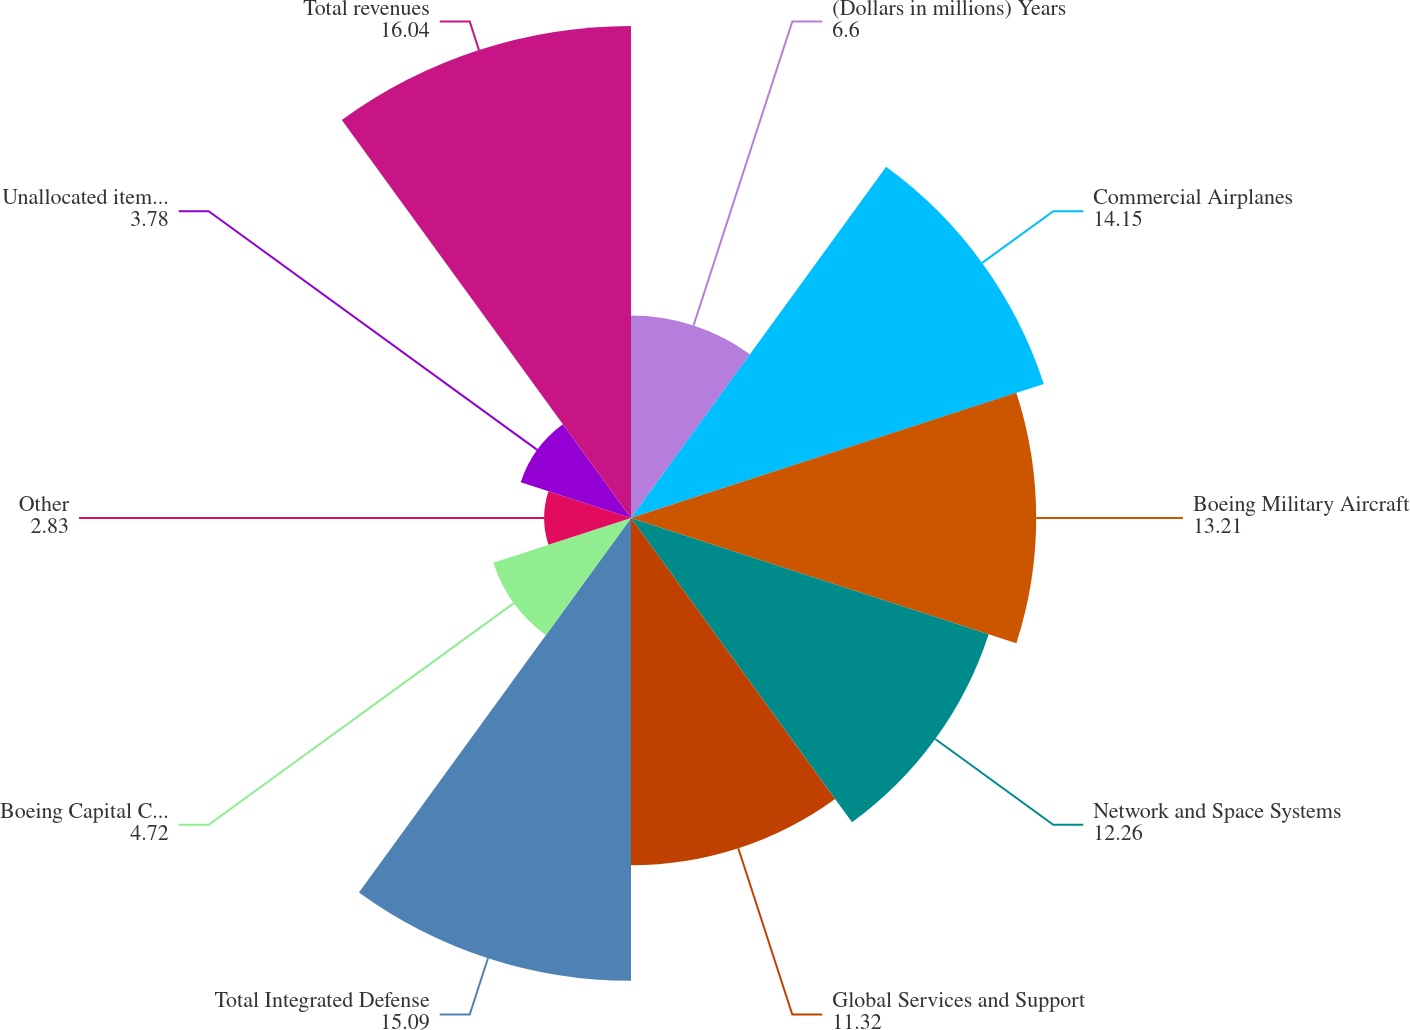Convert chart to OTSL. <chart><loc_0><loc_0><loc_500><loc_500><pie_chart><fcel>(Dollars in millions) Years<fcel>Commercial Airplanes<fcel>Boeing Military Aircraft<fcel>Network and Space Systems<fcel>Global Services and Support<fcel>Total Integrated Defense<fcel>Boeing Capital Corporation<fcel>Other<fcel>Unallocated items and<fcel>Total revenues<nl><fcel>6.6%<fcel>14.15%<fcel>13.21%<fcel>12.26%<fcel>11.32%<fcel>15.09%<fcel>4.72%<fcel>2.83%<fcel>3.78%<fcel>16.04%<nl></chart> 